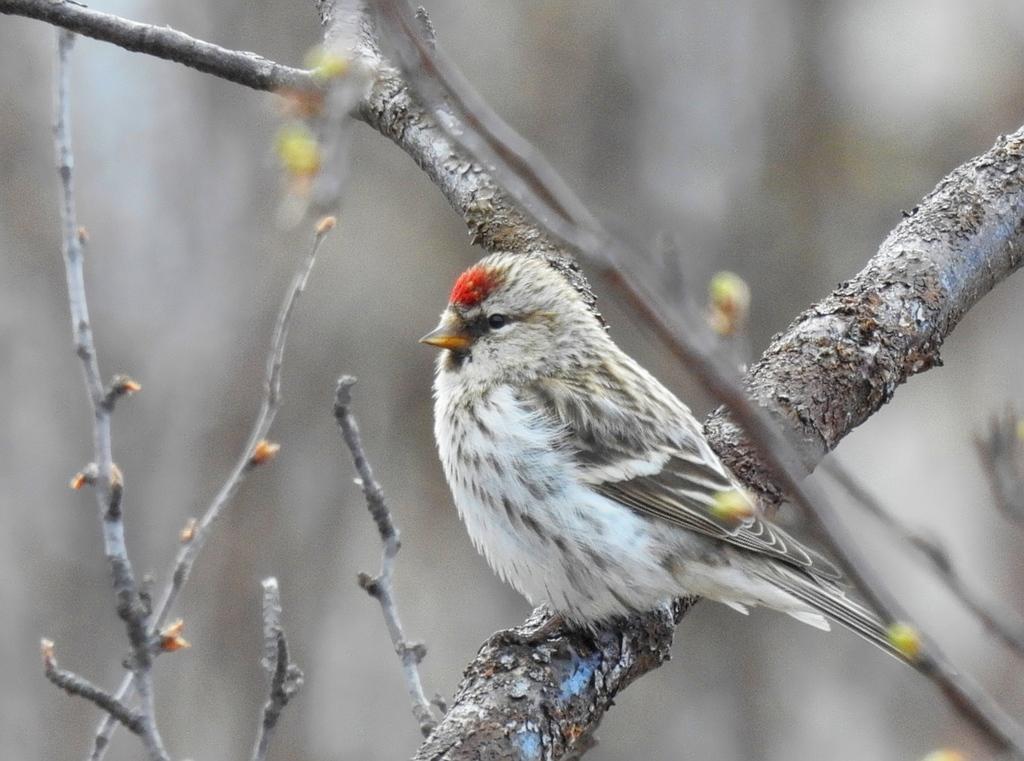Can you describe this image briefly? In this picture we can see a bird on the branch. Behind the bird, there are branches and the blurred background. 